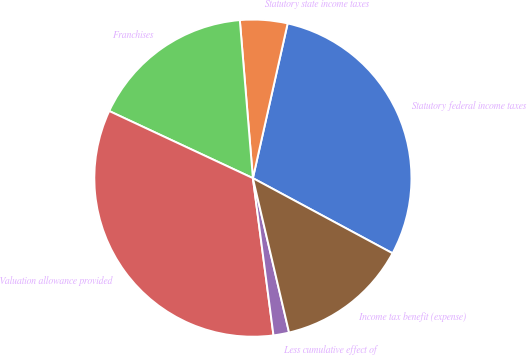<chart> <loc_0><loc_0><loc_500><loc_500><pie_chart><fcel>Statutory federal income taxes<fcel>Statutory state income taxes<fcel>Franchises<fcel>Valuation allowance provided<fcel>Less cumulative effect of<fcel>Income tax benefit (expense)<nl><fcel>29.34%<fcel>4.83%<fcel>16.73%<fcel>34.03%<fcel>1.59%<fcel>13.48%<nl></chart> 